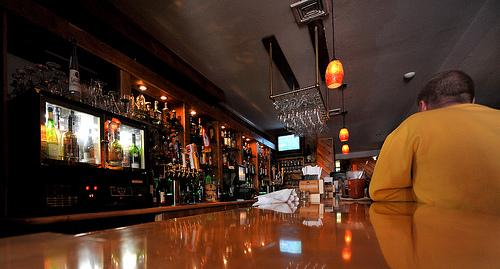What object in the image is for temperature control? The air conditioning vent in the ceiling is for temperature control. What color are the hanging lights from the ceiling? The hanging lights are yellow and orange. What is the most prominent feature in the image related to drinks? The most prominent feature related to drinks are the liquor bottles on the shelves. Describe the scene depicted in the image. The image shows a man in a yellow shirt sitting at a bar surrounded by glasses hanging from the ceiling, liquor bottles on shelves, and a TV reflection on the counter. There are yellow and orange lamps hanging from the roof and a beer tap area for drafts. Mention the details about the hanging glasses in the image. There are several rows of wine glasses hanging upside down in a rack from the ceiling. Describe the lighting in the scene. There are yellow and orange lamps hanging from the roof, recessed lighting fixtures over the shelves, small lighting near the ceiling, and under shelf lighting. What is the color of the cooler with bottles inside? The color of the cooler with bottles inside is black. What type of drink is mentioned in the image with a straw? A bloody mary drink with a straw is mentioned in the image. What is the man at the bar wearing? The man at the bar is wearing a yellow sweater. What kind of appliance is located in the upper corner of the bar? A small television is located in the upper corner of the bar. Which type of glasses are hanging from the ceiling? b) beer mugs Describe the light fixtures above the shelves in the bar. Small recessed lighting fixtures Describe the appearance of the counter. The counter is shiny and reflects lights and television. Describe the black cooler in the image. The black cooler contains bottles and has red lights on it. What type of liquor is being chilled on the top shelf? Top shelf liquor What is the predominant color of the lights hanging from the ceiling? Red and yellow Give a detailed explanation of the condition of the upper corner of the bar. There is a small television and additional shelving present under it Describe the air conditioning vent in the ceiling. It's a rectangular-shaped vent What is the main customer doing at the bar? Sitting and watching television What type of haircut does the man at the bar have? Short haircut Is the man sitting at the bar wearing a blue shirt? The man at the bar is actually wearing a yellow shirt, not a blue one. Is there a bartender pouring a drink in the background of the image? No, it's not mentioned in the image. Is there a green lamp hanging from the ceiling next to the yellow and orange ones? There are only yellow and orange lamps mentioned hanging from the ceiling, not any green ones. What does the man at the bar have on? Yellow shirt and sweatshirt Can you find a white wine bottle on the shelf? There is a mention of a tall glass bottle on the shelf but no information about its content, color, or if it's a wine bottle. Compose a brief description of a scene involving a man at the bar. A man in a yellow shirt with a short haircut is sitting at the bar, watching a small television while having a bloody mary with a straw. Is the man with short hair holding a beer in his hand? There is no mention of the man with short hair holding anything in his hand, let alone a beer. Does the wine glass hanging in the rack have a red liquid inside it? There is no mention of any wine glass containing any liquid, let alone a red one. Identify an event that is happening at the bar. Man sitting and watching a small television What is the role of the woman in the bar? Bar maid What can be found hanging from the ceiling? Yellow and orange lamps What is the function of the under shelf lighting? To illuminate the bar shelves What can be found inside the refrigerator unit with lighting? Green and yellow bottles What is a unique feature of the wine glasses hanging from the ceiling? They are upside down Which drink has a straw in it? Bloody mary drink What is the action taking place at the counter of the bar? Man leaning his elbow on the counter 